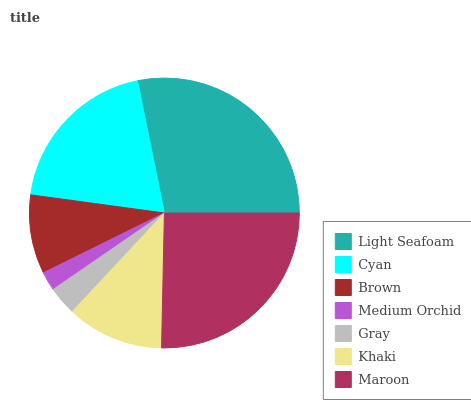Is Medium Orchid the minimum?
Answer yes or no. Yes. Is Light Seafoam the maximum?
Answer yes or no. Yes. Is Cyan the minimum?
Answer yes or no. No. Is Cyan the maximum?
Answer yes or no. No. Is Light Seafoam greater than Cyan?
Answer yes or no. Yes. Is Cyan less than Light Seafoam?
Answer yes or no. Yes. Is Cyan greater than Light Seafoam?
Answer yes or no. No. Is Light Seafoam less than Cyan?
Answer yes or no. No. Is Khaki the high median?
Answer yes or no. Yes. Is Khaki the low median?
Answer yes or no. Yes. Is Medium Orchid the high median?
Answer yes or no. No. Is Cyan the low median?
Answer yes or no. No. 